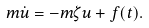<formula> <loc_0><loc_0><loc_500><loc_500>m \dot { u } = - m \zeta u + f ( t ) .</formula> 